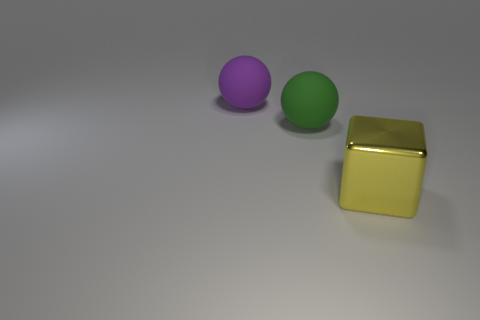Add 3 yellow blocks. How many objects exist? 6 Subtract all blocks. How many objects are left? 2 Add 1 large red matte blocks. How many large red matte blocks exist? 1 Subtract 1 yellow cubes. How many objects are left? 2 Subtract all large green metal things. Subtract all big yellow blocks. How many objects are left? 2 Add 2 yellow metallic objects. How many yellow metallic objects are left? 3 